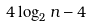<formula> <loc_0><loc_0><loc_500><loc_500>4 \log _ { 2 } n - 4</formula> 